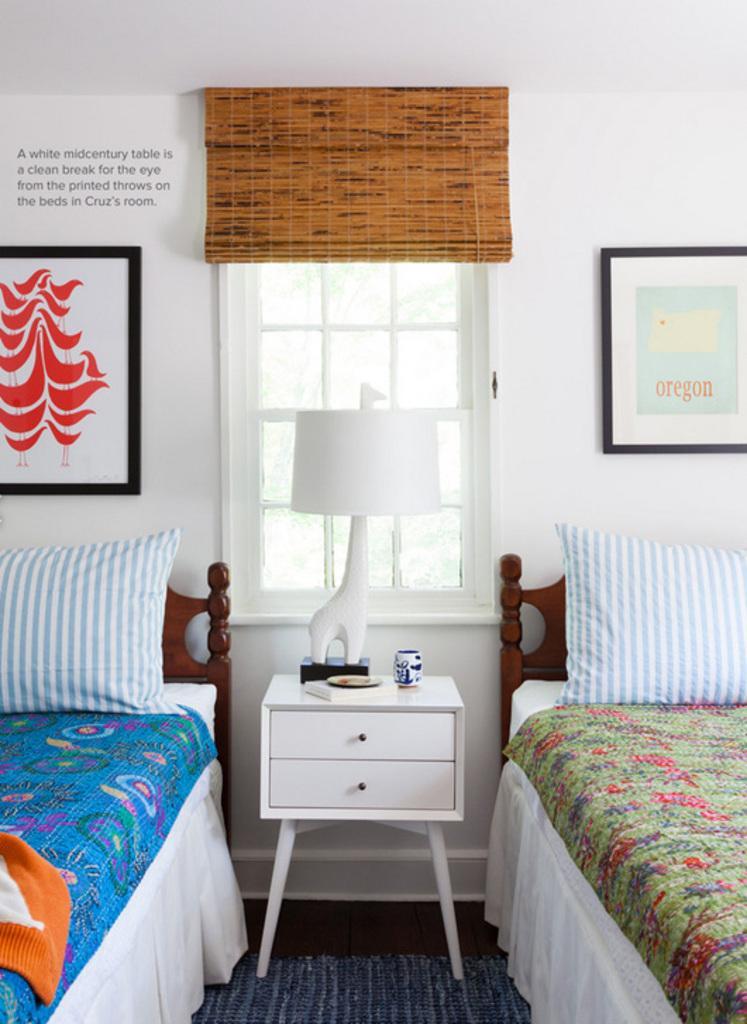Please provide a concise description of this image. In this image i can see 2 beds, 2 pillows,a drawer, a lamp, a window and the wall, and i can see 2 photo frames attached to the wall. 